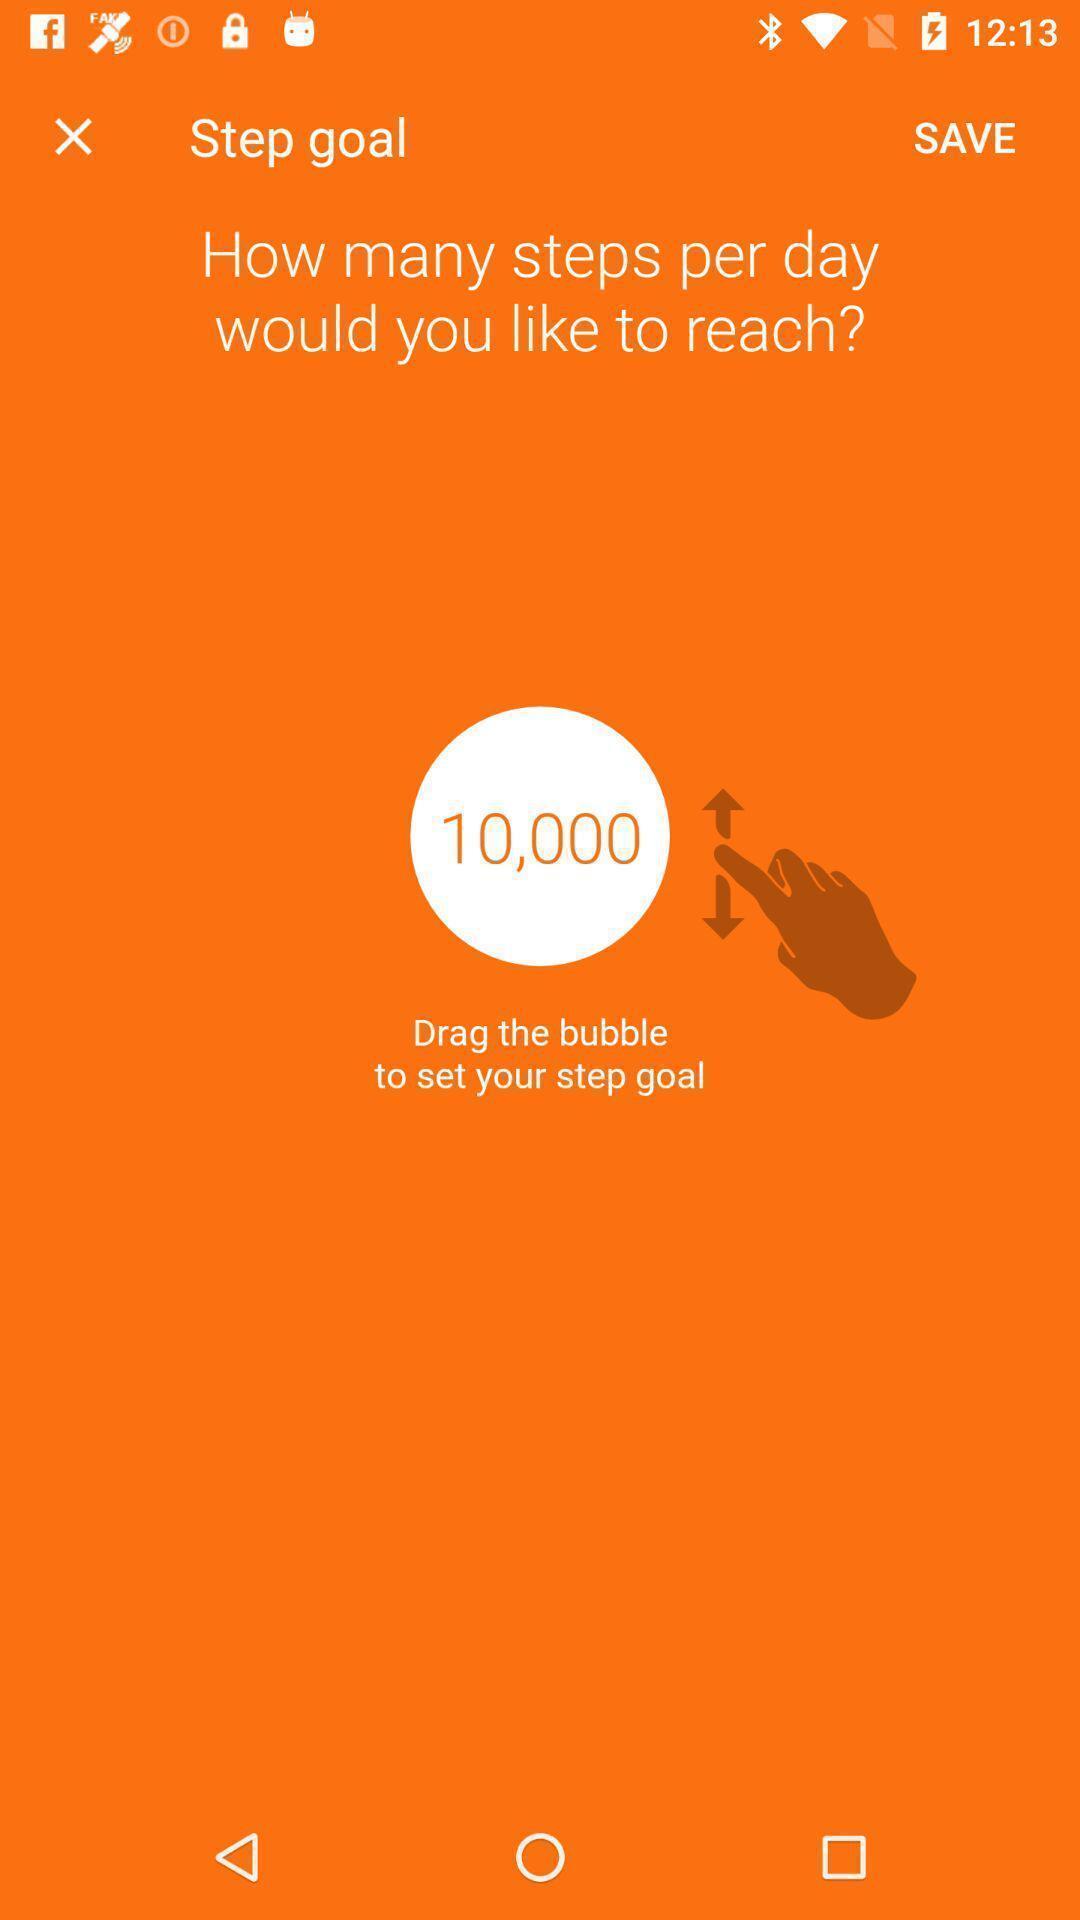Tell me about the visual elements in this screen capture. Page to setup a goal in the health fitness app. 